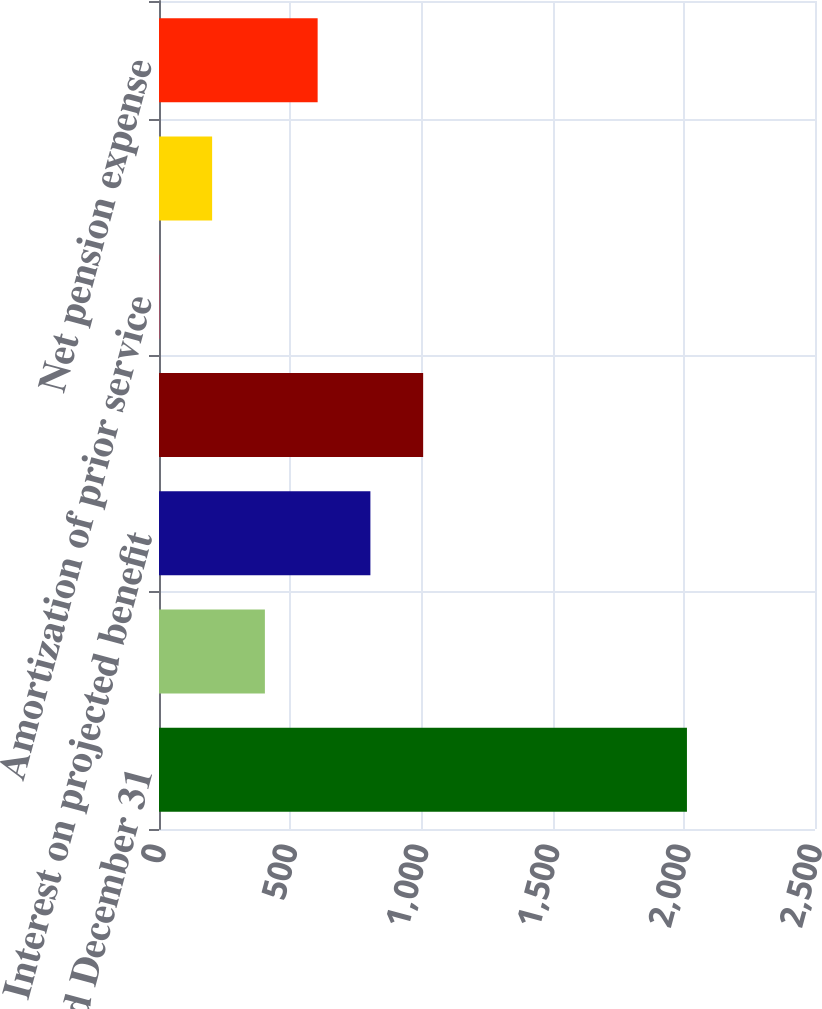<chart> <loc_0><loc_0><loc_500><loc_500><bar_chart><fcel>Year Ended December 31<fcel>Service cost<fcel>Interest on projected benefit<fcel>Expected return on assets<fcel>Amortization of prior service<fcel>Recognized actuarial loss<fcel>Net pension expense<nl><fcel>2012<fcel>403.52<fcel>805.64<fcel>1006.7<fcel>1.4<fcel>202.46<fcel>604.58<nl></chart> 